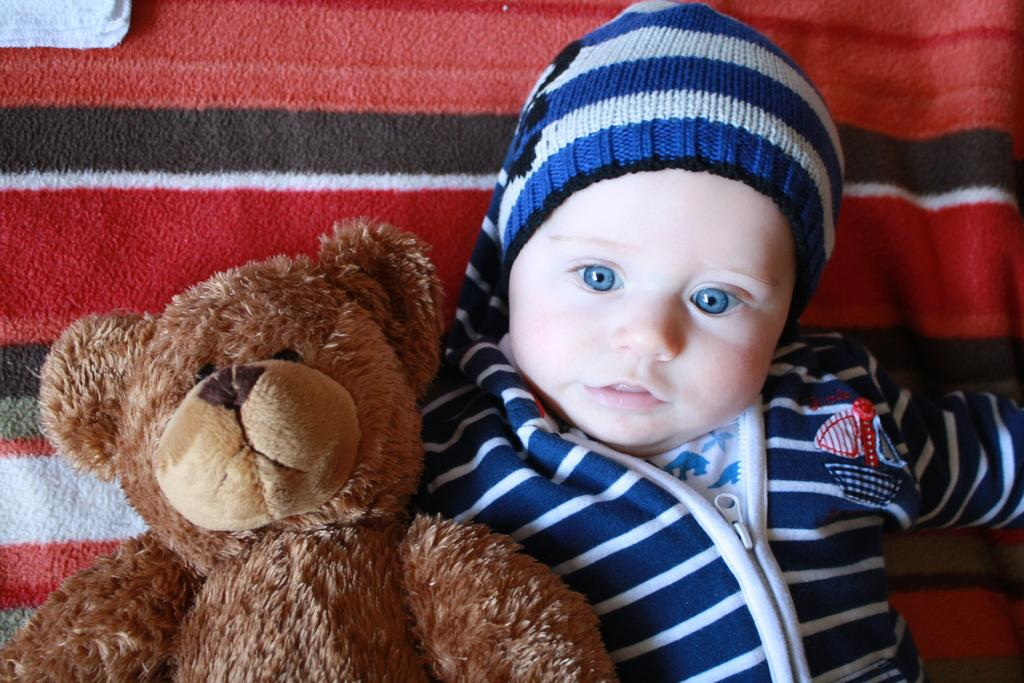What is the main subject of the image? There is a baby in the image. What is the baby laying on? The baby is laying on a red color bed-sheet. Are there any other objects or figures in the image? Yes, there is a teddy bear beside the baby. What type of cream is being applied to the baby during the operation in the image? There is no operation or cream present in the image; it features a baby laying on a red bed-sheet with a teddy bear beside them. Can you see a plane flying in the background of the image? There is no plane visible in the image; it focuses on the baby, the bed-sheet, and the teddy bear. 